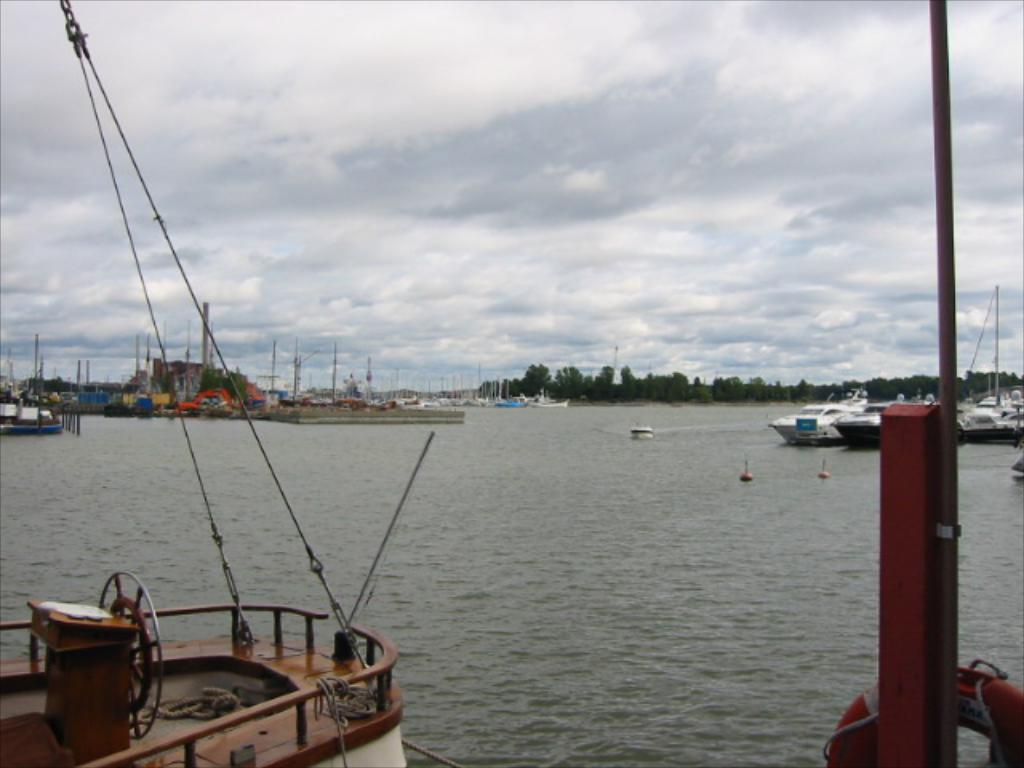What is the main subject of the image? The main subject of the image is water. What is present on the water? There are boats on the water. What can be seen in the background of the image? There are trees and clouds in the background of the image. What else is visible in the background of the image? The sky is visible in the background of the image. What type of toys can be seen floating in the water in the image? There are no toys present in the image; it features water with boats and a background of trees, clouds, and sky. What is the size of the yarn used to create the clouds in the image? There is no yarn present in the image, as the clouds are a natural part of the sky. 